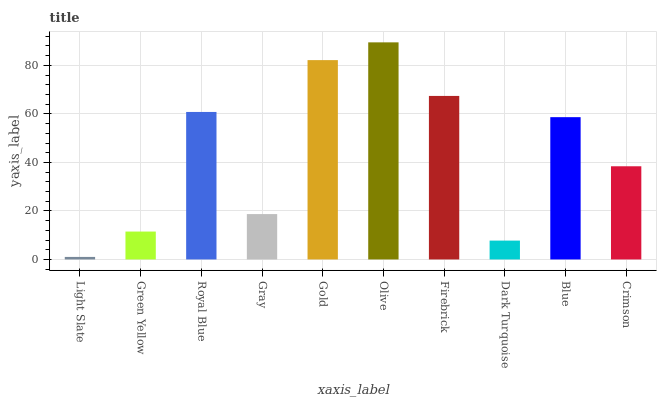Is Light Slate the minimum?
Answer yes or no. Yes. Is Olive the maximum?
Answer yes or no. Yes. Is Green Yellow the minimum?
Answer yes or no. No. Is Green Yellow the maximum?
Answer yes or no. No. Is Green Yellow greater than Light Slate?
Answer yes or no. Yes. Is Light Slate less than Green Yellow?
Answer yes or no. Yes. Is Light Slate greater than Green Yellow?
Answer yes or no. No. Is Green Yellow less than Light Slate?
Answer yes or no. No. Is Blue the high median?
Answer yes or no. Yes. Is Crimson the low median?
Answer yes or no. Yes. Is Gray the high median?
Answer yes or no. No. Is Dark Turquoise the low median?
Answer yes or no. No. 